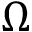<formula> <loc_0><loc_0><loc_500><loc_500>\Omega</formula> 